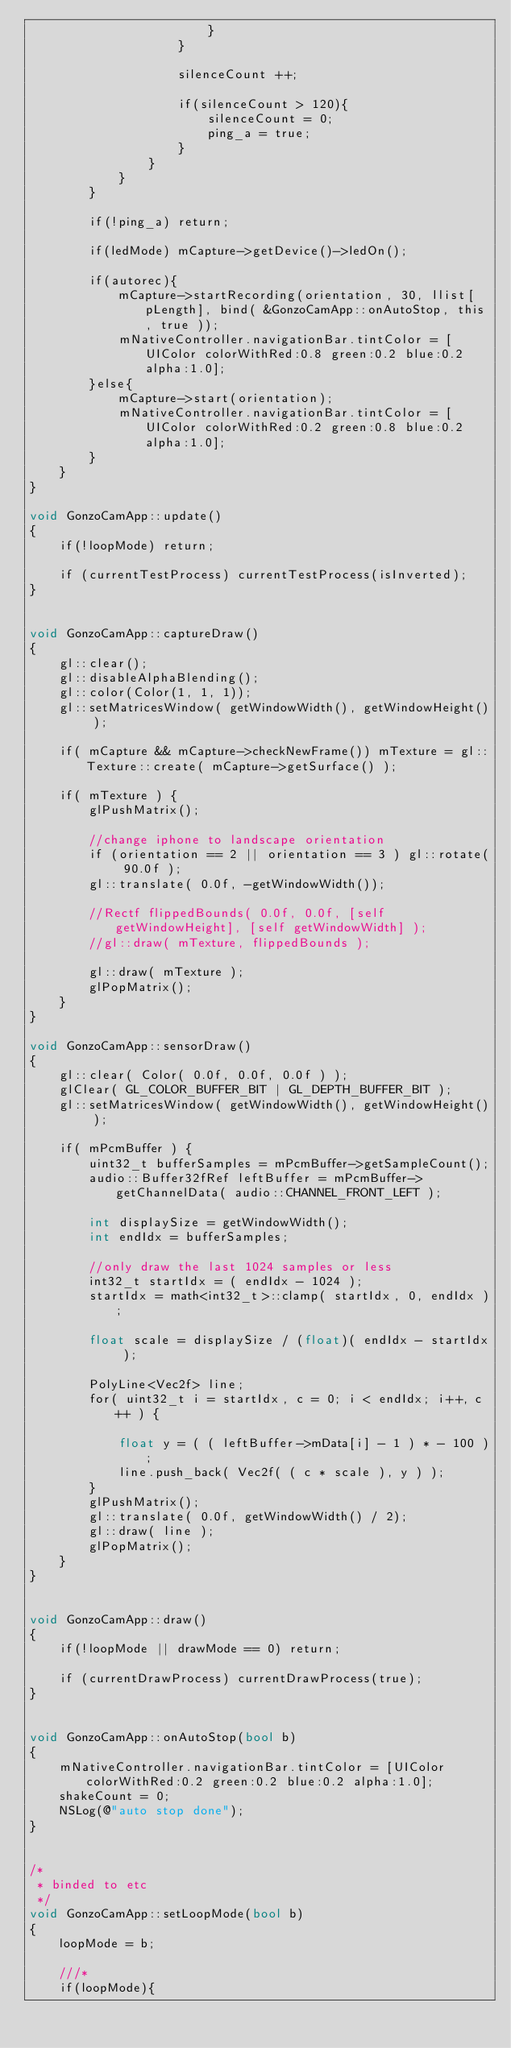Convert code to text. <code><loc_0><loc_0><loc_500><loc_500><_ObjectiveC_>                        }
                    }
                    
                    silenceCount ++;
                    
                    if(silenceCount > 120){
                        silenceCount = 0;
                        ping_a = true;
                    }
                }
            }
        }
        
        if(!ping_a) return;
        
        if(ledMode) mCapture->getDevice()->ledOn();
        
        if(autorec){
            mCapture->startRecording(orientation, 30, llist[pLength], bind( &GonzoCamApp::onAutoStop, this, true ));
            mNativeController.navigationBar.tintColor = [UIColor colorWithRed:0.8 green:0.2 blue:0.2 alpha:1.0];
        }else{
            mCapture->start(orientation);
            mNativeController.navigationBar.tintColor = [UIColor colorWithRed:0.2 green:0.8 blue:0.2 alpha:1.0];
        }
    }
}

void GonzoCamApp::update()
{
    if(!loopMode) return;

    if (currentTestProcess) currentTestProcess(isInverted);
}


void GonzoCamApp::captureDraw()
{
    gl::clear();
    gl::disableAlphaBlending();
    gl::color(Color(1, 1, 1));
    gl::setMatricesWindow( getWindowWidth(), getWindowHeight() );
    
    if( mCapture && mCapture->checkNewFrame()) mTexture = gl::Texture::create( mCapture->getSurface() );
    
    if( mTexture ) {
        glPushMatrix();
        
        //change iphone to landscape orientation
        if (orientation == 2 || orientation == 3 ) gl::rotate( 90.0f );
        gl::translate( 0.0f, -getWindowWidth());
        
        //Rectf flippedBounds( 0.0f, 0.0f, [self getWindowHeight], [self getWindowWidth] );
        //gl::draw( mTexture, flippedBounds );
        
        gl::draw( mTexture );
        glPopMatrix();
    }
}

void GonzoCamApp::sensorDraw()
{
    gl::clear( Color( 0.0f, 0.0f, 0.0f ) );
    glClear( GL_COLOR_BUFFER_BIT | GL_DEPTH_BUFFER_BIT );
    gl::setMatricesWindow( getWindowWidth(), getWindowHeight() );
    
    if( mPcmBuffer ) {
        uint32_t bufferSamples = mPcmBuffer->getSampleCount();
        audio::Buffer32fRef leftBuffer = mPcmBuffer->getChannelData( audio::CHANNEL_FRONT_LEFT );
        
        int displaySize = getWindowWidth();
        int endIdx = bufferSamples;
        
        //only draw the last 1024 samples or less
        int32_t startIdx = ( endIdx - 1024 );
        startIdx = math<int32_t>::clamp( startIdx, 0, endIdx );
        
        float scale = displaySize / (float)( endIdx - startIdx );
        
        PolyLine<Vec2f>	line;
        for( uint32_t i = startIdx, c = 0; i < endIdx; i++, c++ ) {
            
            float y = ( ( leftBuffer->mData[i] - 1 ) * - 100 );
            line.push_back( Vec2f( ( c * scale ), y ) );
        }
        glPushMatrix();
        gl::translate( 0.0f, getWindowWidth() / 2);
        gl::draw( line );
        glPopMatrix();
    }
}


void GonzoCamApp::draw()
{
    if(!loopMode || drawMode == 0) return;
    
    if (currentDrawProcess) currentDrawProcess(true);
}


void GonzoCamApp::onAutoStop(bool b)
{
    mNativeController.navigationBar.tintColor = [UIColor colorWithRed:0.2 green:0.2 blue:0.2 alpha:1.0];
    shakeCount = 0;
    NSLog(@"auto stop done");
}


/*
 * binded to etc
 */
void GonzoCamApp::setLoopMode(bool b)
{
    loopMode = b;
    
    ///*
    if(loopMode){</code> 